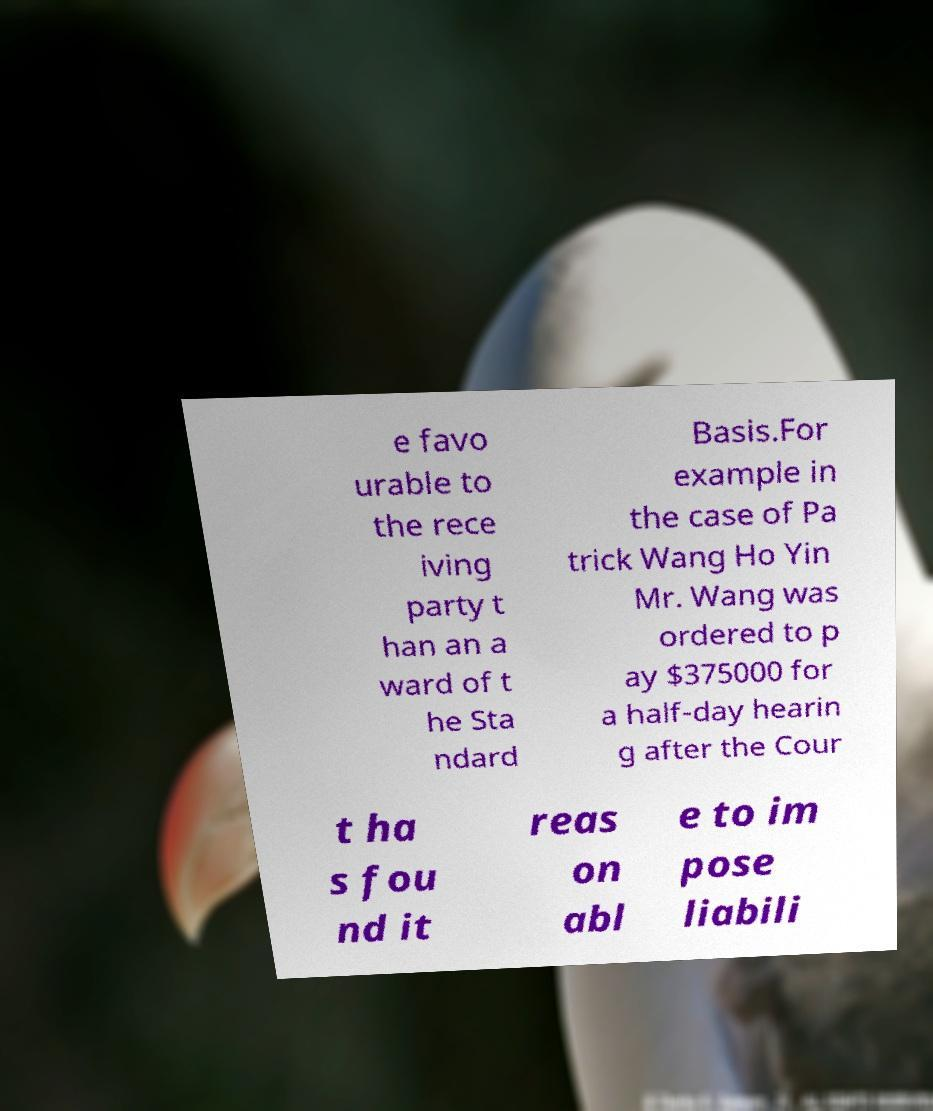I need the written content from this picture converted into text. Can you do that? e favo urable to the rece iving party t han an a ward of t he Sta ndard Basis.For example in the case of Pa trick Wang Ho Yin Mr. Wang was ordered to p ay $375000 for a half-day hearin g after the Cour t ha s fou nd it reas on abl e to im pose liabili 